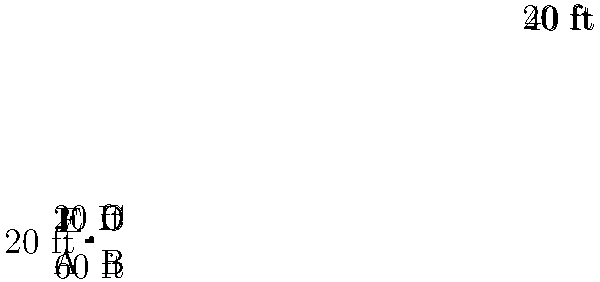You're considering investing in a piece of property with an irregularly shaped lot. The dimensions are shown in the diagram above. What is the total area of this property lot in square feet? To find the area of this irregularly shaped lot, we can break it down into two rectangles:

1. The larger rectangle (ABCF):
   Length = 60 ft
   Width = 20 ft
   Area of larger rectangle = $60 \times 20 = 1200$ sq ft

2. The smaller rectangle (CDEF):
   Length = 20 ft
   Width = 20 ft
   Area of smaller rectangle = $20 \times 20 = 400$ sq ft

Now, we add the areas of these two rectangles:

Total Area = Area of larger rectangle + Area of smaller rectangle
           = $1200 + 400$
           = $1600$ sq ft

Therefore, the total area of the property lot is 1600 square feet.
Answer: 1600 sq ft 